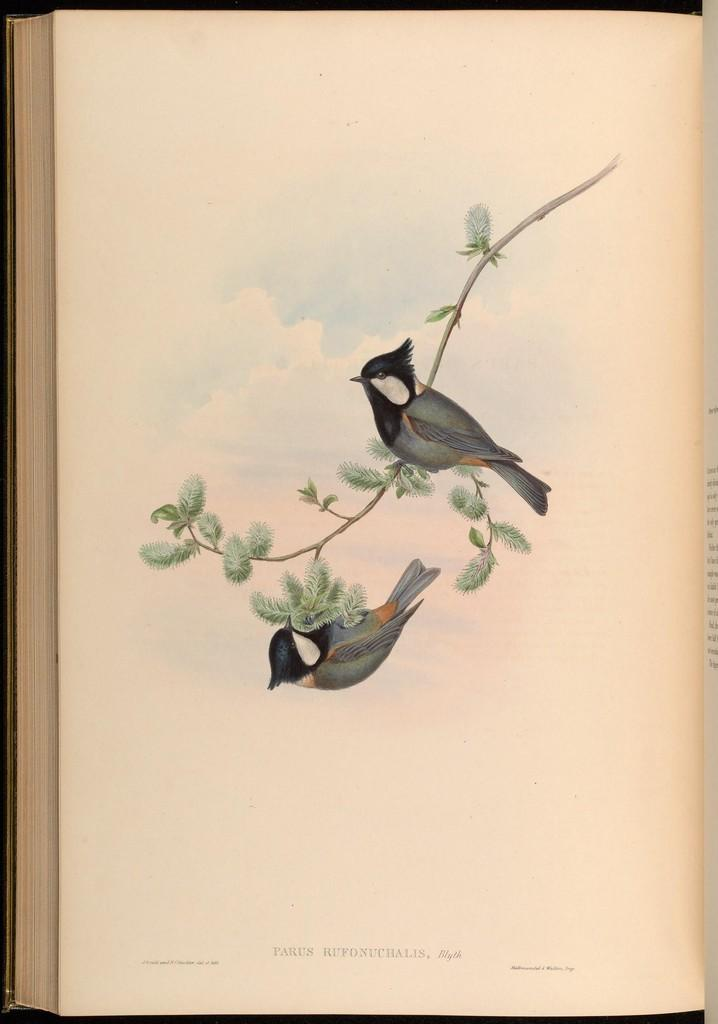What is the main object in the image? There is a book in the image. What can be found on one of the pages of the book? The book has a page with a painting of birds. What else is included in the painting? The painting includes a stem with leaves. Is there any text on the page with the painting? Yes, there is text on the page. What is the ground made of in the image? There is no ground present in the image, as it is a painting of birds on a page of a book. 